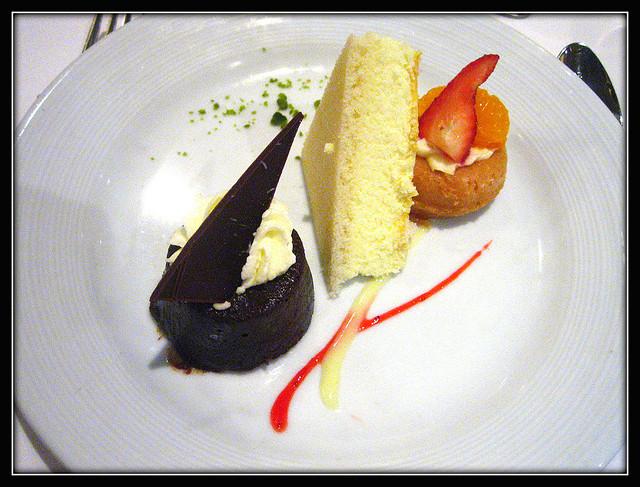What color is the plate?
Be succinct. White. Is this before or after dinner?
Answer briefly. After. Where are the desserts?
Be succinct. Plate. 